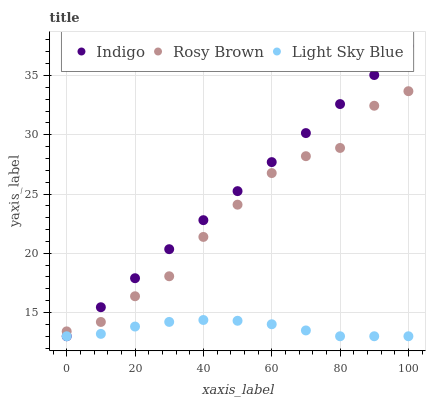Does Light Sky Blue have the minimum area under the curve?
Answer yes or no. Yes. Does Indigo have the maximum area under the curve?
Answer yes or no. Yes. Does Indigo have the minimum area under the curve?
Answer yes or no. No. Does Light Sky Blue have the maximum area under the curve?
Answer yes or no. No. Is Indigo the smoothest?
Answer yes or no. Yes. Is Rosy Brown the roughest?
Answer yes or no. Yes. Is Light Sky Blue the smoothest?
Answer yes or no. No. Is Light Sky Blue the roughest?
Answer yes or no. No. Does Indigo have the lowest value?
Answer yes or no. Yes. Does Indigo have the highest value?
Answer yes or no. Yes. Does Light Sky Blue have the highest value?
Answer yes or no. No. Is Light Sky Blue less than Rosy Brown?
Answer yes or no. Yes. Is Rosy Brown greater than Light Sky Blue?
Answer yes or no. Yes. Does Light Sky Blue intersect Indigo?
Answer yes or no. Yes. Is Light Sky Blue less than Indigo?
Answer yes or no. No. Is Light Sky Blue greater than Indigo?
Answer yes or no. No. Does Light Sky Blue intersect Rosy Brown?
Answer yes or no. No. 